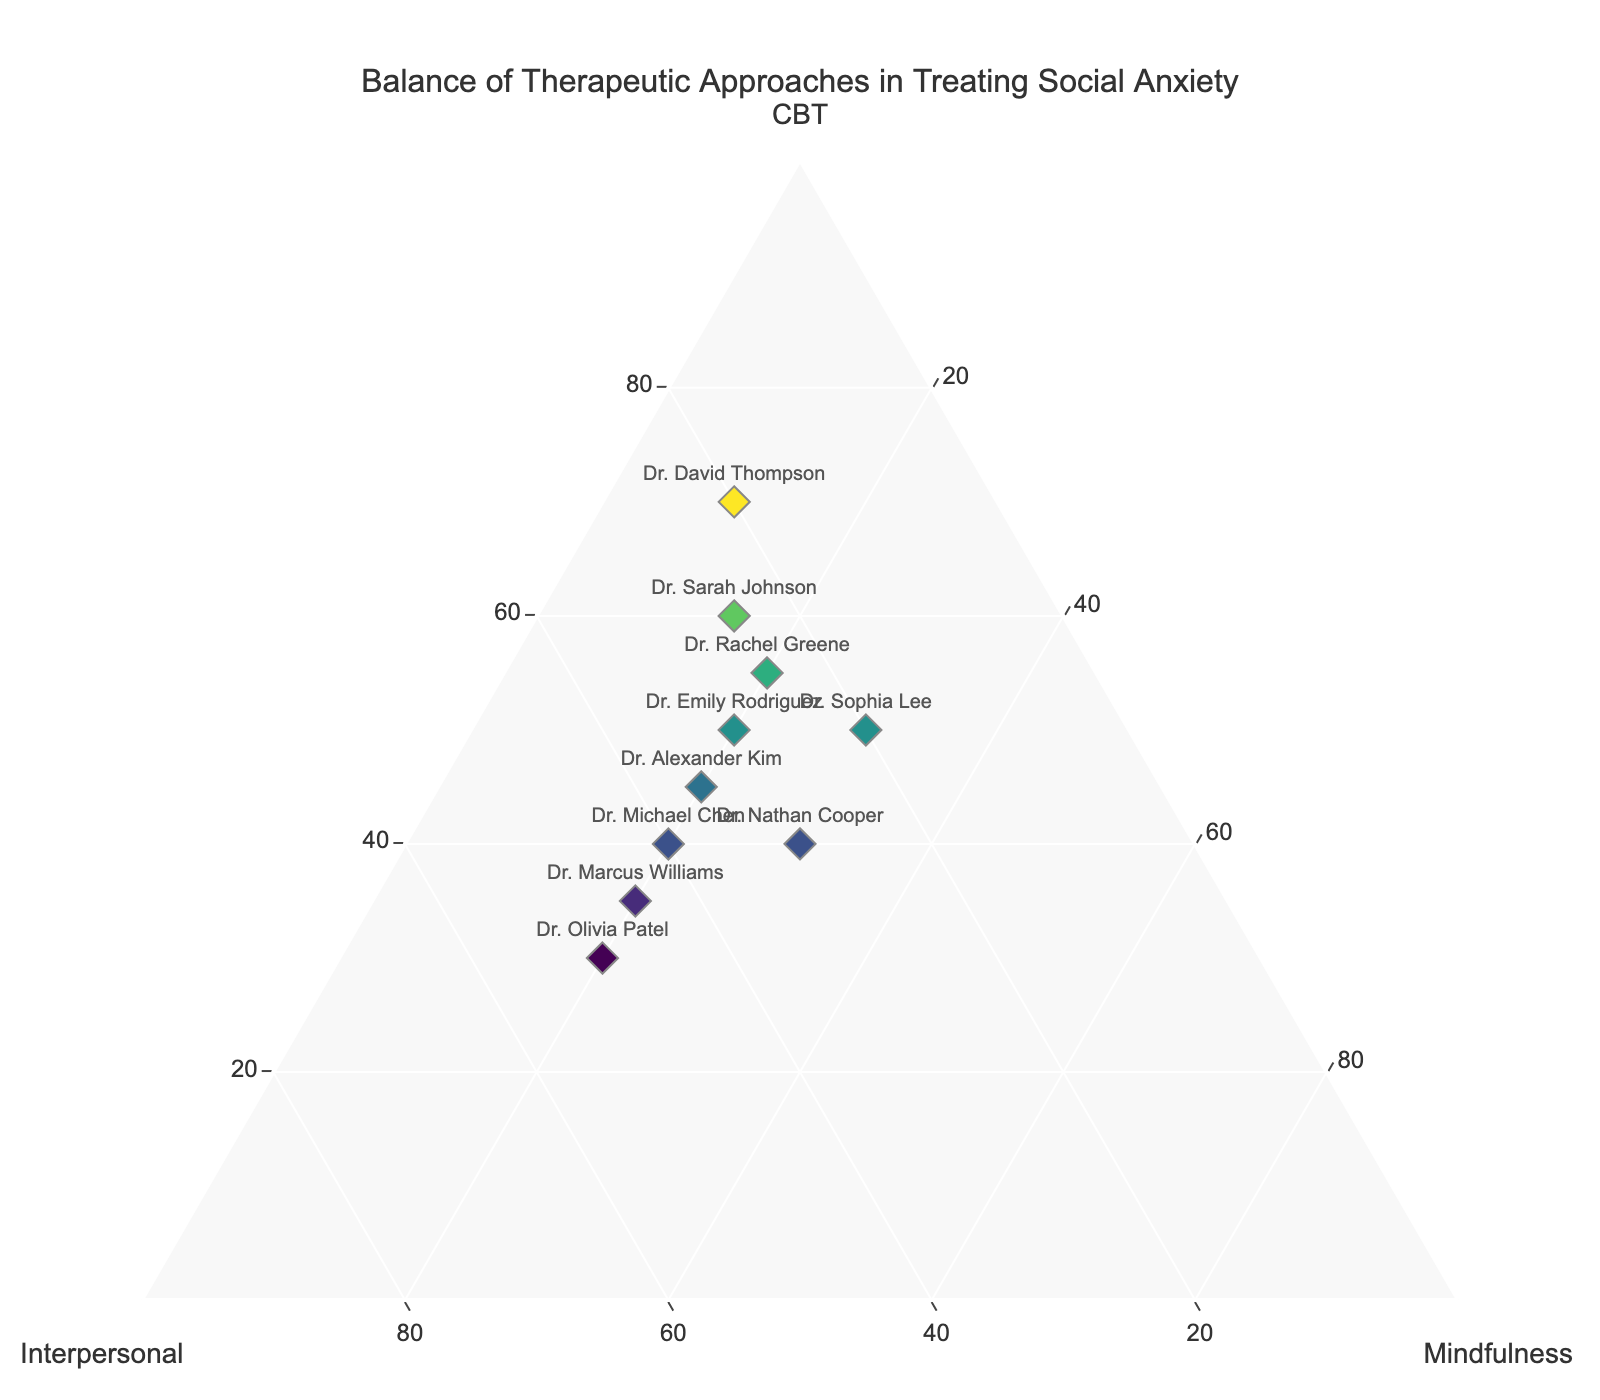What is the title of the figure? The title of the figure is usually displayed at the top. In this case, the title is clearly written at the top center of the figure.
Answer: Balance of Therapeutic Approaches in Treating Social Anxiety How many therapists are represented in the plot? To determine the number of therapists, count the number of unique data points shown on the plot. Each point is marked with the therapist's name.
Answer: 10 Which therapist has the highest proportion of Cognitive Behavioral Therapy (CBT)? Identify the data point that has the highest value for the 'a' axis, which corresponds to CBT. Dr. David Thompson has the highest 'a' value of 70.
Answer: Dr. David Thompson What is the combined proportion of CBT and Interpersonal approaches for Dr. Emily Rodriguez? Look at Dr. Emily Rodriguez's data point, which shows 50 for CBT ('a' axis) and 30 for Interpersonal ('b' axis). Add these values together.
Answer: 80 Compare the CBT approach proportion between Dr. Sarah Johnson and Dr. Marcus Williams. Who uses it more? Dr. Sarah Johnson has a CBT proportion of 60, while Dr. Marcus Williams has 35. Compare these numbers to determine the answer.
Answer: Dr. Sarah Johnson Which therapist uses the highest proportion of Mindfulness approaches? Identify the data point with the highest value for the 'c' axis. Dr. Sophia Lee has the highest 'c' value of 30.
Answer: Dr. Sophia Lee What is the difference in the proportion of CBT between Dr. Rachel Greene and Dr. Olivia Patel? Look at the CBT values ('a' values): Dr. Rachel Greene has 55 and Dr. Olivia Patel has 30. Subtract these values.
Answer: 25 Combine the proportions of all three therapeutic approaches for Dr. Alexander Kim. What should this sum be, according to the figure's rules? According to the rules of the ternary plot, the sum of all three approaches must equal 100. For Dr. Alexander Kim, CBT = 45, Interpersonal = 35, and Mindfulness = 20. Add these to confirm the sum.
Answer: 100 Who has a proportion of Interpersonal approaches equal to their proportion of Mindfulness approaches? Find the data points where the 'b' axis (Interpersonal) and 'c' axis (Mindfulness) proportions are equal. Dr. Michael Chen has 40 for both Interpersonal and Mindfulness.
Answer: Dr. Michael Chen Which therapist's approach is the most balanced among all three types? The most balanced approach would have similar values across all three axes. Dr. Nathan Cooper, with 40 for CBT, 30 for Interpersonal, and 30 for Mindfulness, shows the most balance.
Answer: Dr. Nathan Cooper 